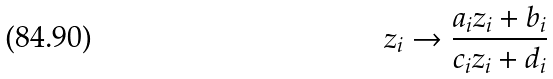<formula> <loc_0><loc_0><loc_500><loc_500>z _ { i } \rightarrow \frac { a _ { i } z _ { i } + b _ { i } } { c _ { i } z _ { i } + d _ { i } }</formula> 